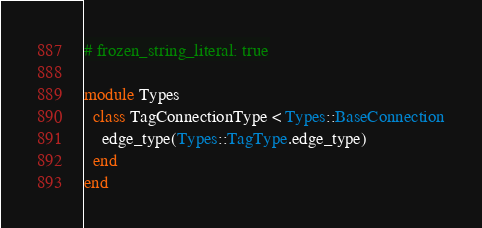<code> <loc_0><loc_0><loc_500><loc_500><_Ruby_># frozen_string_literal: true

module Types
  class TagConnectionType < Types::BaseConnection
    edge_type(Types::TagType.edge_type)
  end
end
</code> 